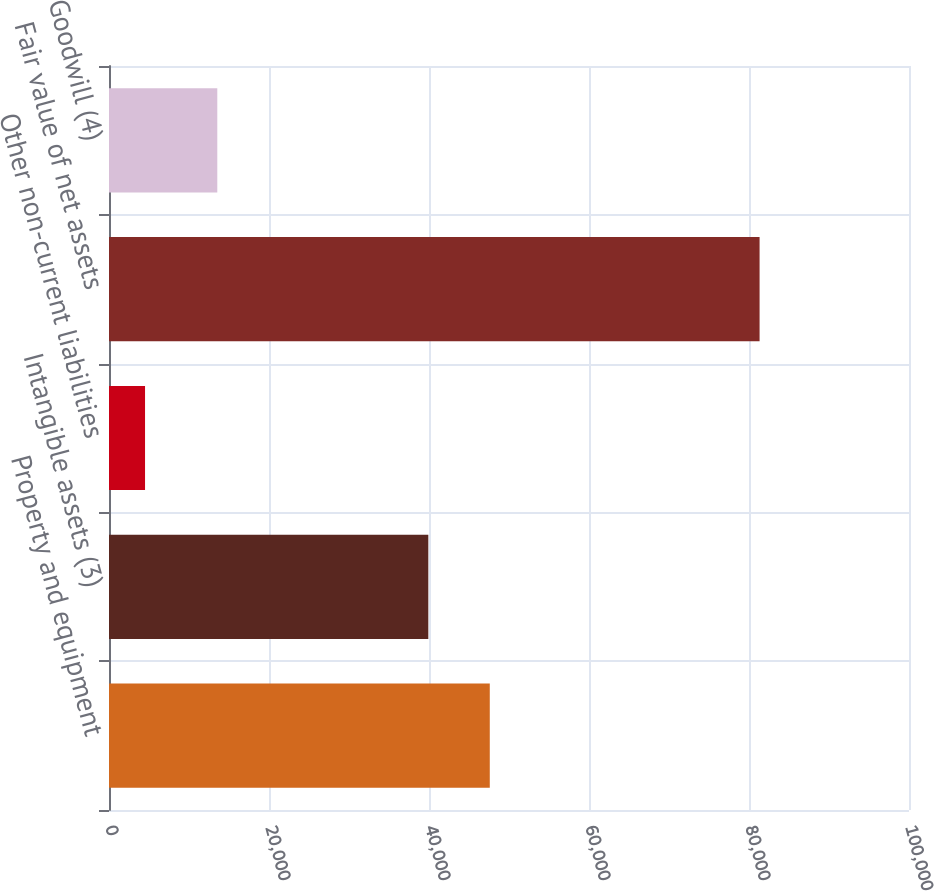Convert chart. <chart><loc_0><loc_0><loc_500><loc_500><bar_chart><fcel>Property and equipment<fcel>Intangible assets (3)<fcel>Other non-current liabilities<fcel>Fair value of net assets<fcel>Goodwill (4)<nl><fcel>47597.8<fcel>39916<fcel>4505<fcel>81323<fcel>13537<nl></chart> 